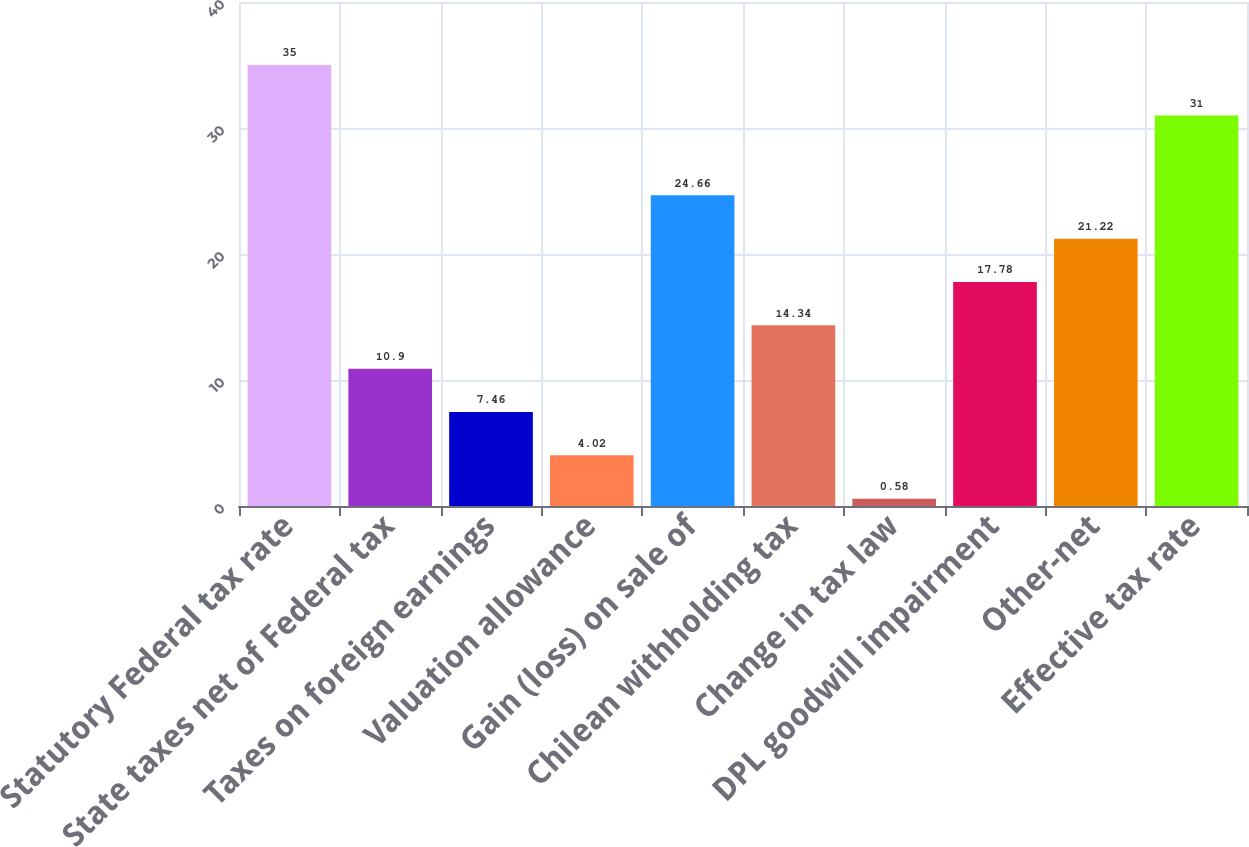<chart> <loc_0><loc_0><loc_500><loc_500><bar_chart><fcel>Statutory Federal tax rate<fcel>State taxes net of Federal tax<fcel>Taxes on foreign earnings<fcel>Valuation allowance<fcel>Gain (loss) on sale of<fcel>Chilean withholding tax<fcel>Change in tax law<fcel>DPL goodwill impairment<fcel>Other-net<fcel>Effective tax rate<nl><fcel>35<fcel>10.9<fcel>7.46<fcel>4.02<fcel>24.66<fcel>14.34<fcel>0.58<fcel>17.78<fcel>21.22<fcel>31<nl></chart> 